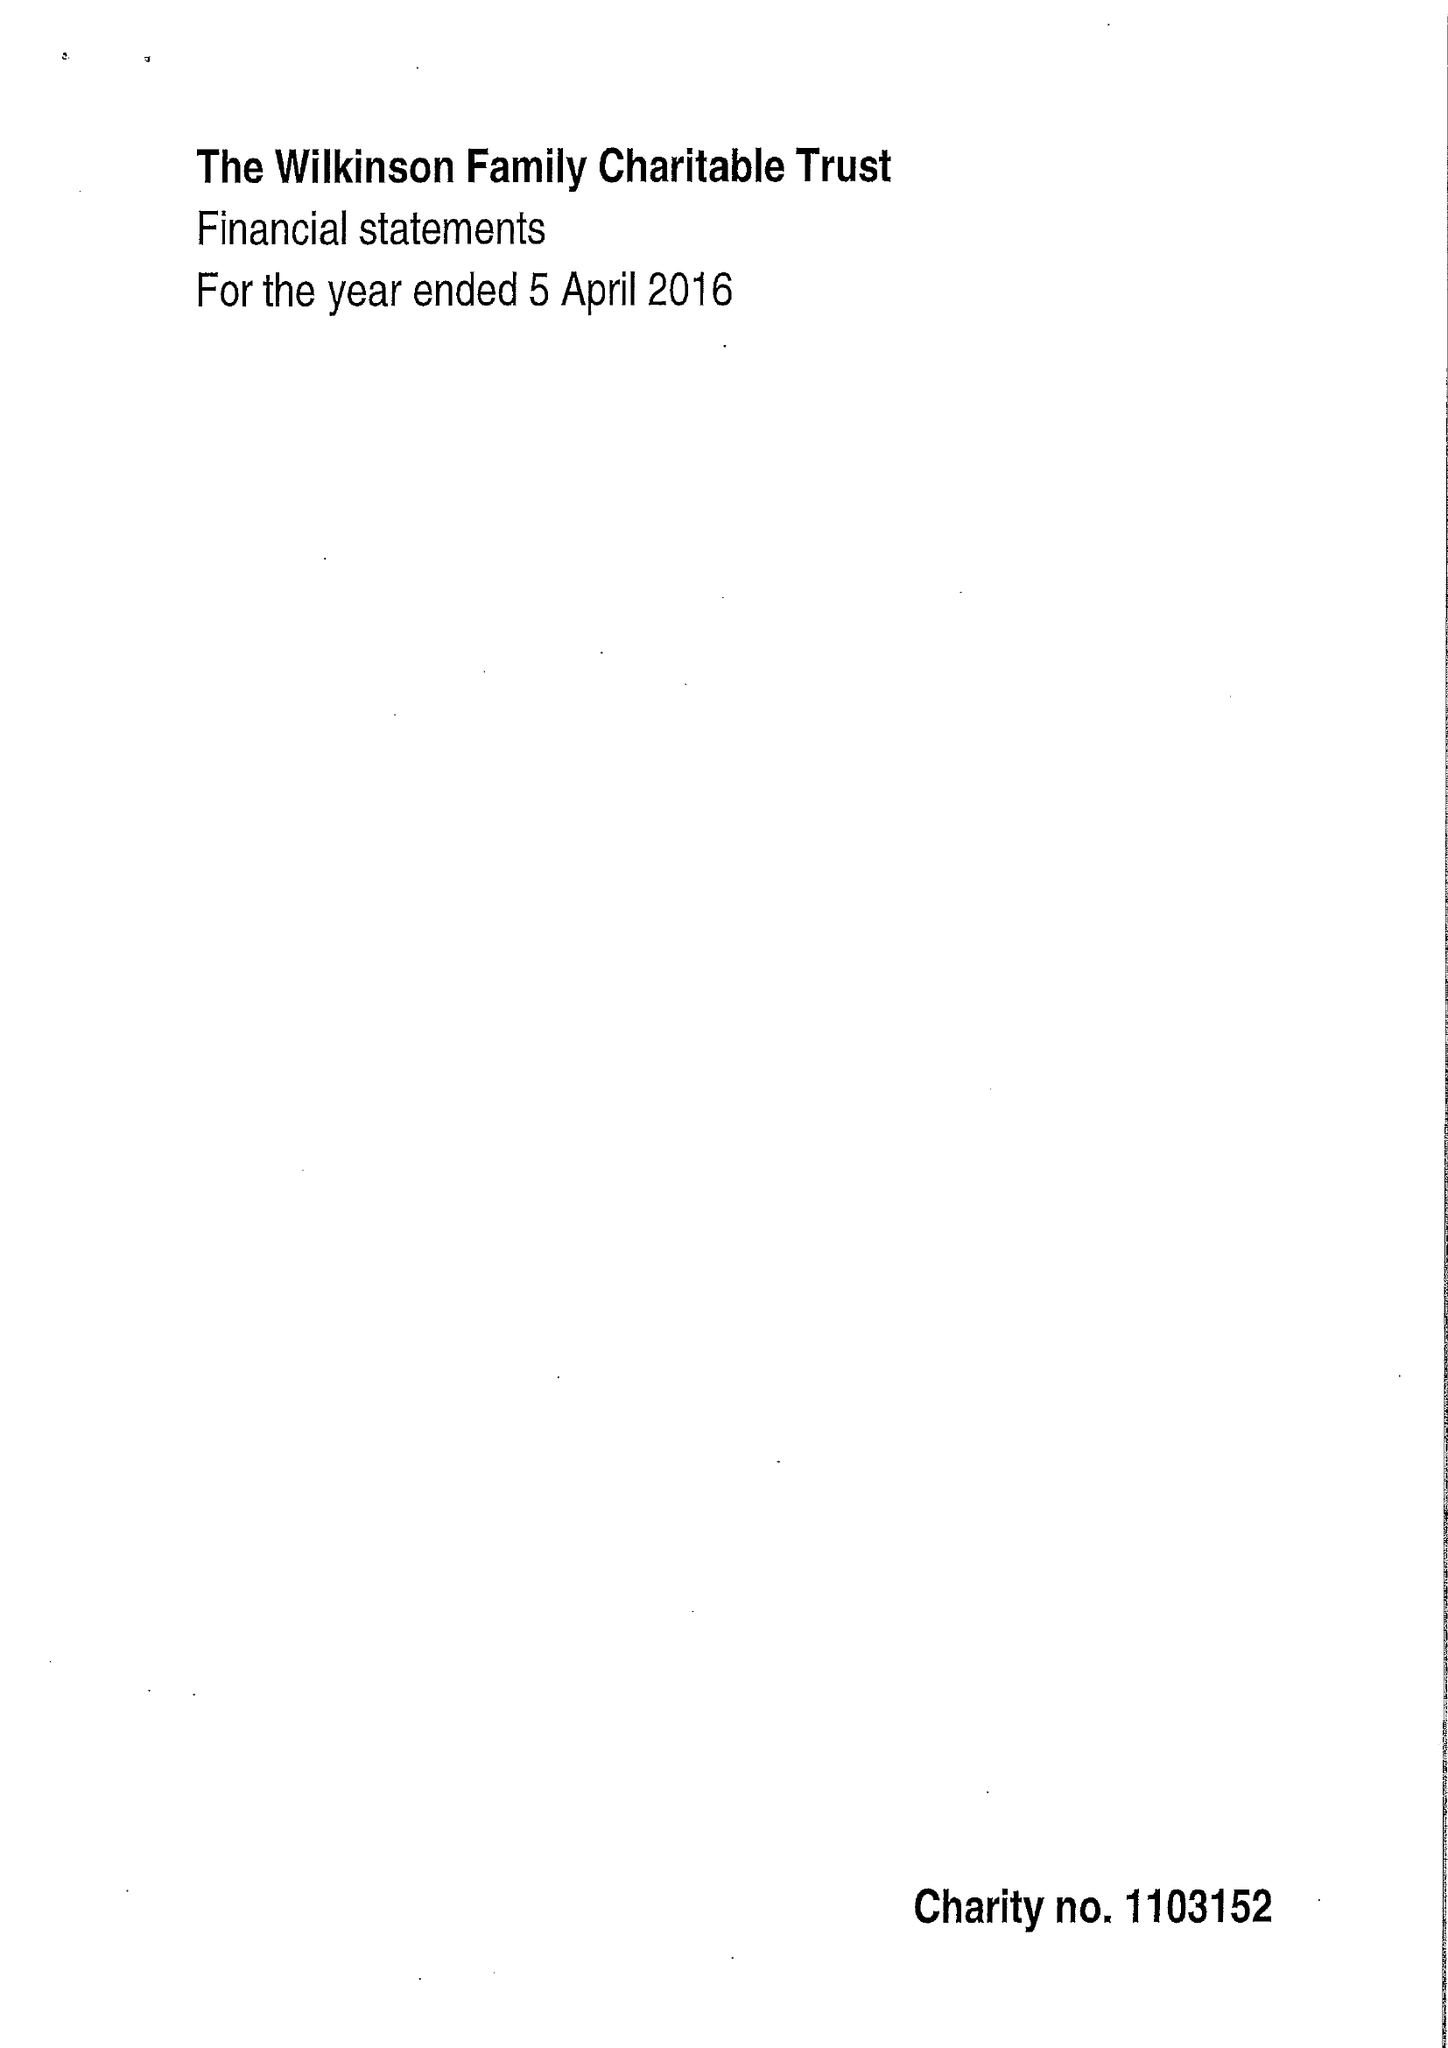What is the value for the charity_number?
Answer the question using a single word or phrase. 1103152 